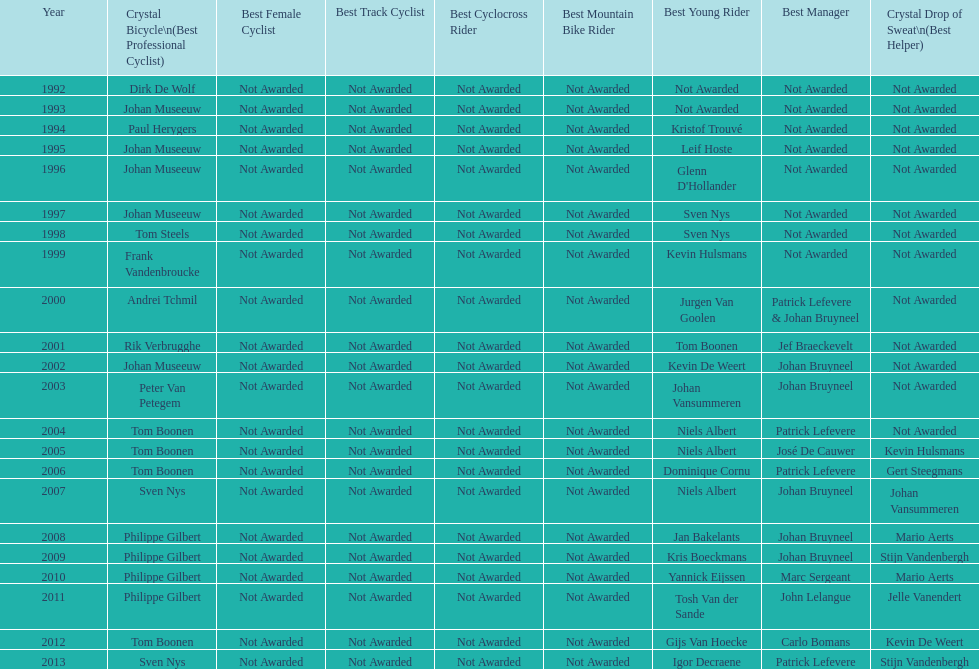Who has won the most best young rider awards? Niels Albert. 